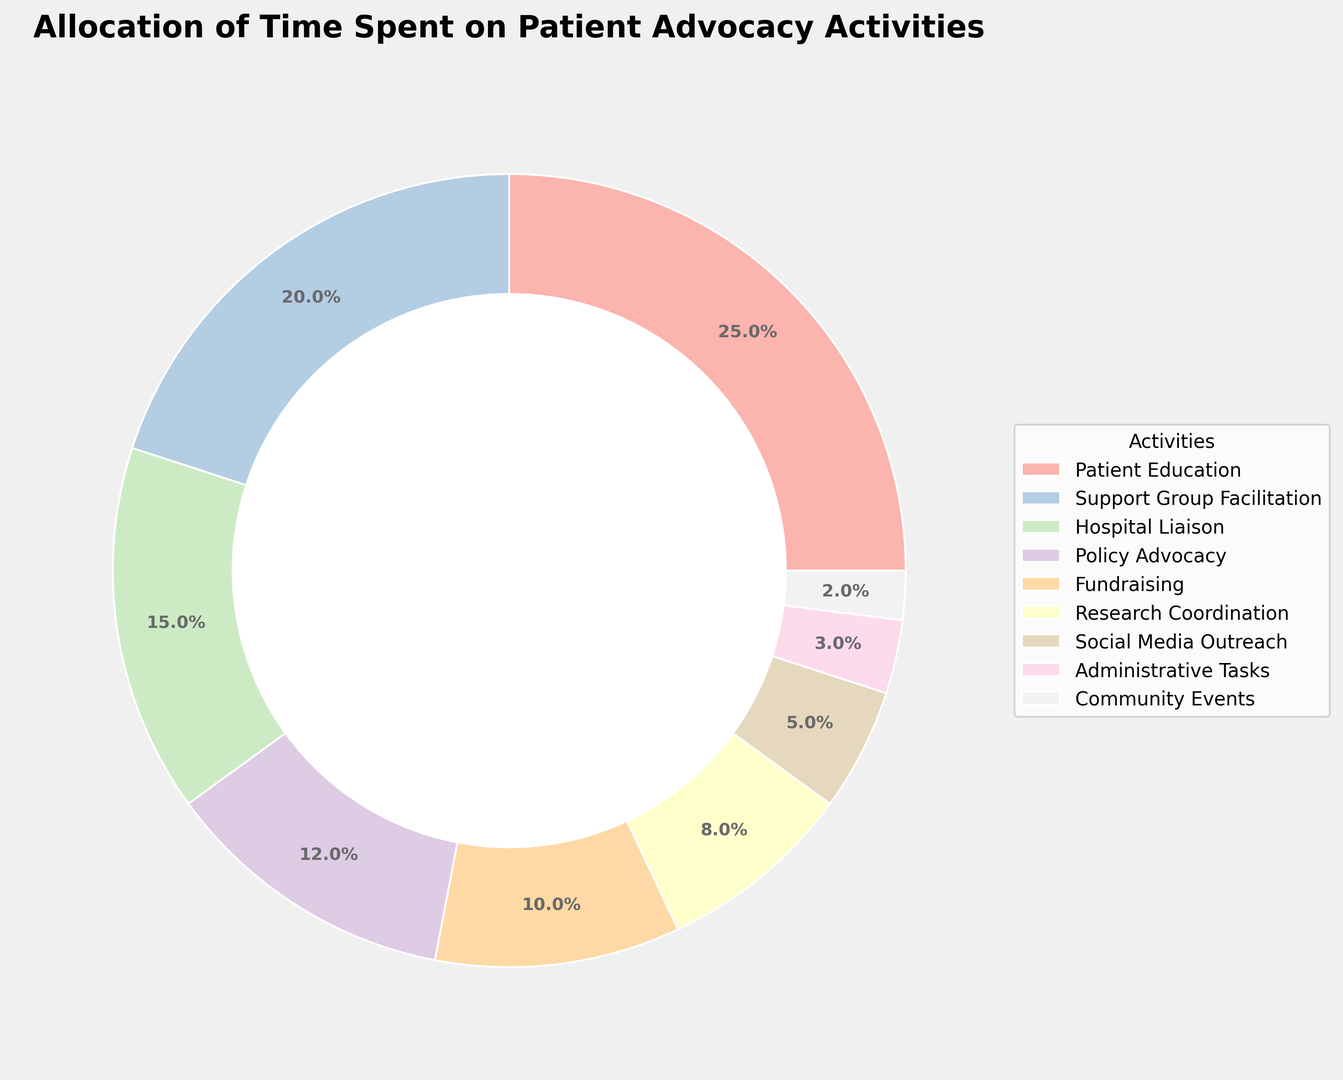Which activity takes up the most time? The Patient Education takes up the most time as indicated by the largest section of the ring chart.
Answer: Patient Education Which activity spends 15% of the total time? The Hospital Liaison is labeled with 15% and is clearly marked on the ring chart.
Answer: Hospital Liaison What is the combined percentage of time spent on Policy Advocacy and Fundraising? The Policy Advocacy takes 12% and Fundraising takes 10%. Adding these together results in 12 + 10 = 22%.
Answer: 22% How does the time spent on Support Group Facilitation compare to time spent on Research Coordination? Support Group Facilitation is 20%, whereas Research Coordination is 8%. So, Support Group Facilitation takes more time than Research Coordination.
Answer: More What percentage of time is allocated to activities under 5%? Social Media Outreach at 5%, Administrative Tasks at 3%, and Community Events at 2%. Adding these results in 5 + 3 + 2 = 10%.
Answer: 10% How much more time is spent on Patient Education than on Social Media Outreach? Patient Education is 25%, and Social Media Outreach is 5%. The difference is 25 - 5 = 20%.
Answer: 20% Which color segment corresponds to the smallest percentage allocation? The smallest segment, representing 2%, corresponds to Community Events.
Answer: Community Events If we combine the percentages of Hospital Liaison and Support Group Facilitation, how does the result compare to the percentage spent on Patient Education? Hospital Liaison is 15% and Support Group Facilitation is 20%, combining these results in 15 + 20 = 35%. This is more than the 25% spent on Patient Education.
Answer: More What is the second most time-consuming activity? Support Group Facilitation takes up the second-largest portion at 20%.
Answer: Support Group Facilitation 